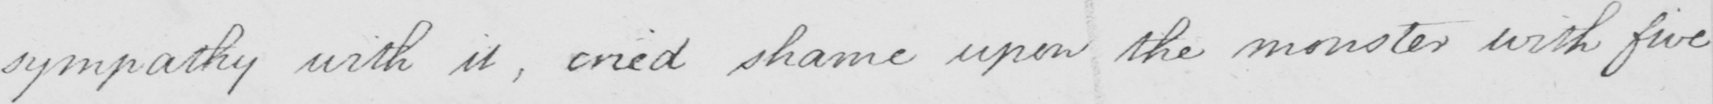Can you tell me what this handwritten text says? sympathy with it , cried shame upon the monster with five 